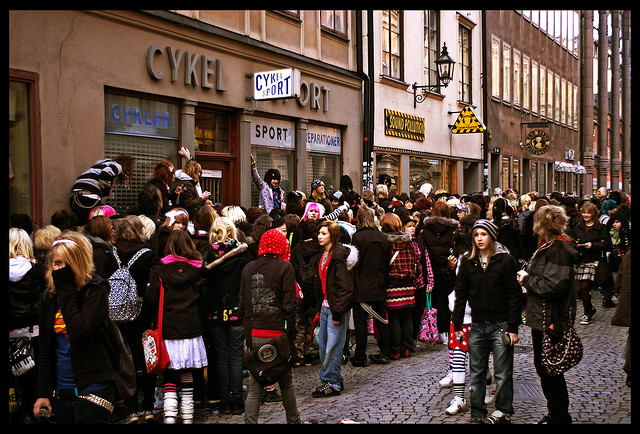<image>Is this in America? I am not sure if this is in America. Is this in America? I don't know if this is in America. It can be somewhere else. 